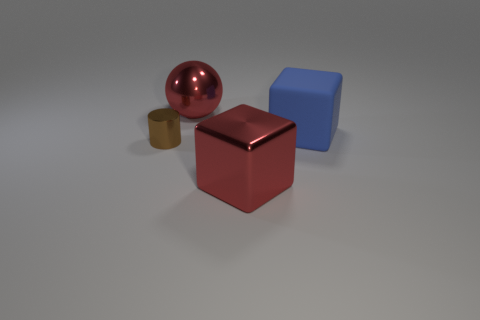Add 1 large blue matte things. How many objects exist? 5 Subtract all cylinders. How many objects are left? 3 Subtract 0 blue balls. How many objects are left? 4 Subtract all big blue rubber blocks. Subtract all big blocks. How many objects are left? 1 Add 1 matte cubes. How many matte cubes are left? 2 Add 1 tiny purple metallic cylinders. How many tiny purple metallic cylinders exist? 1 